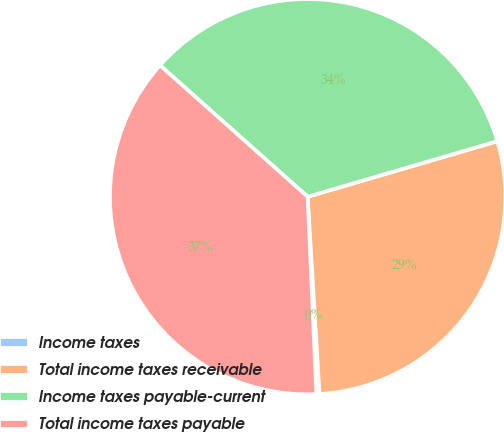<chart> <loc_0><loc_0><loc_500><loc_500><pie_chart><fcel>Income taxes<fcel>Total income taxes receivable<fcel>Income taxes payable-current<fcel>Total income taxes payable<nl><fcel>0.25%<fcel>28.58%<fcel>33.89%<fcel>37.28%<nl></chart> 